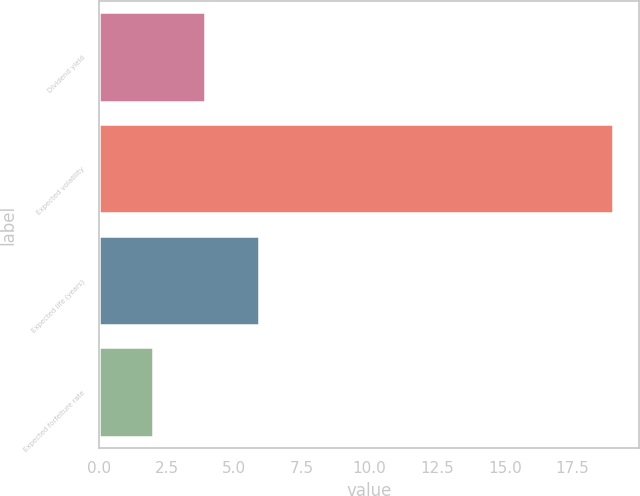Convert chart to OTSL. <chart><loc_0><loc_0><loc_500><loc_500><bar_chart><fcel>Dividend yield<fcel>Expected volatility<fcel>Expected life (years)<fcel>Expected forfeiture rate<nl><fcel>3.9<fcel>19<fcel>5.9<fcel>2<nl></chart> 